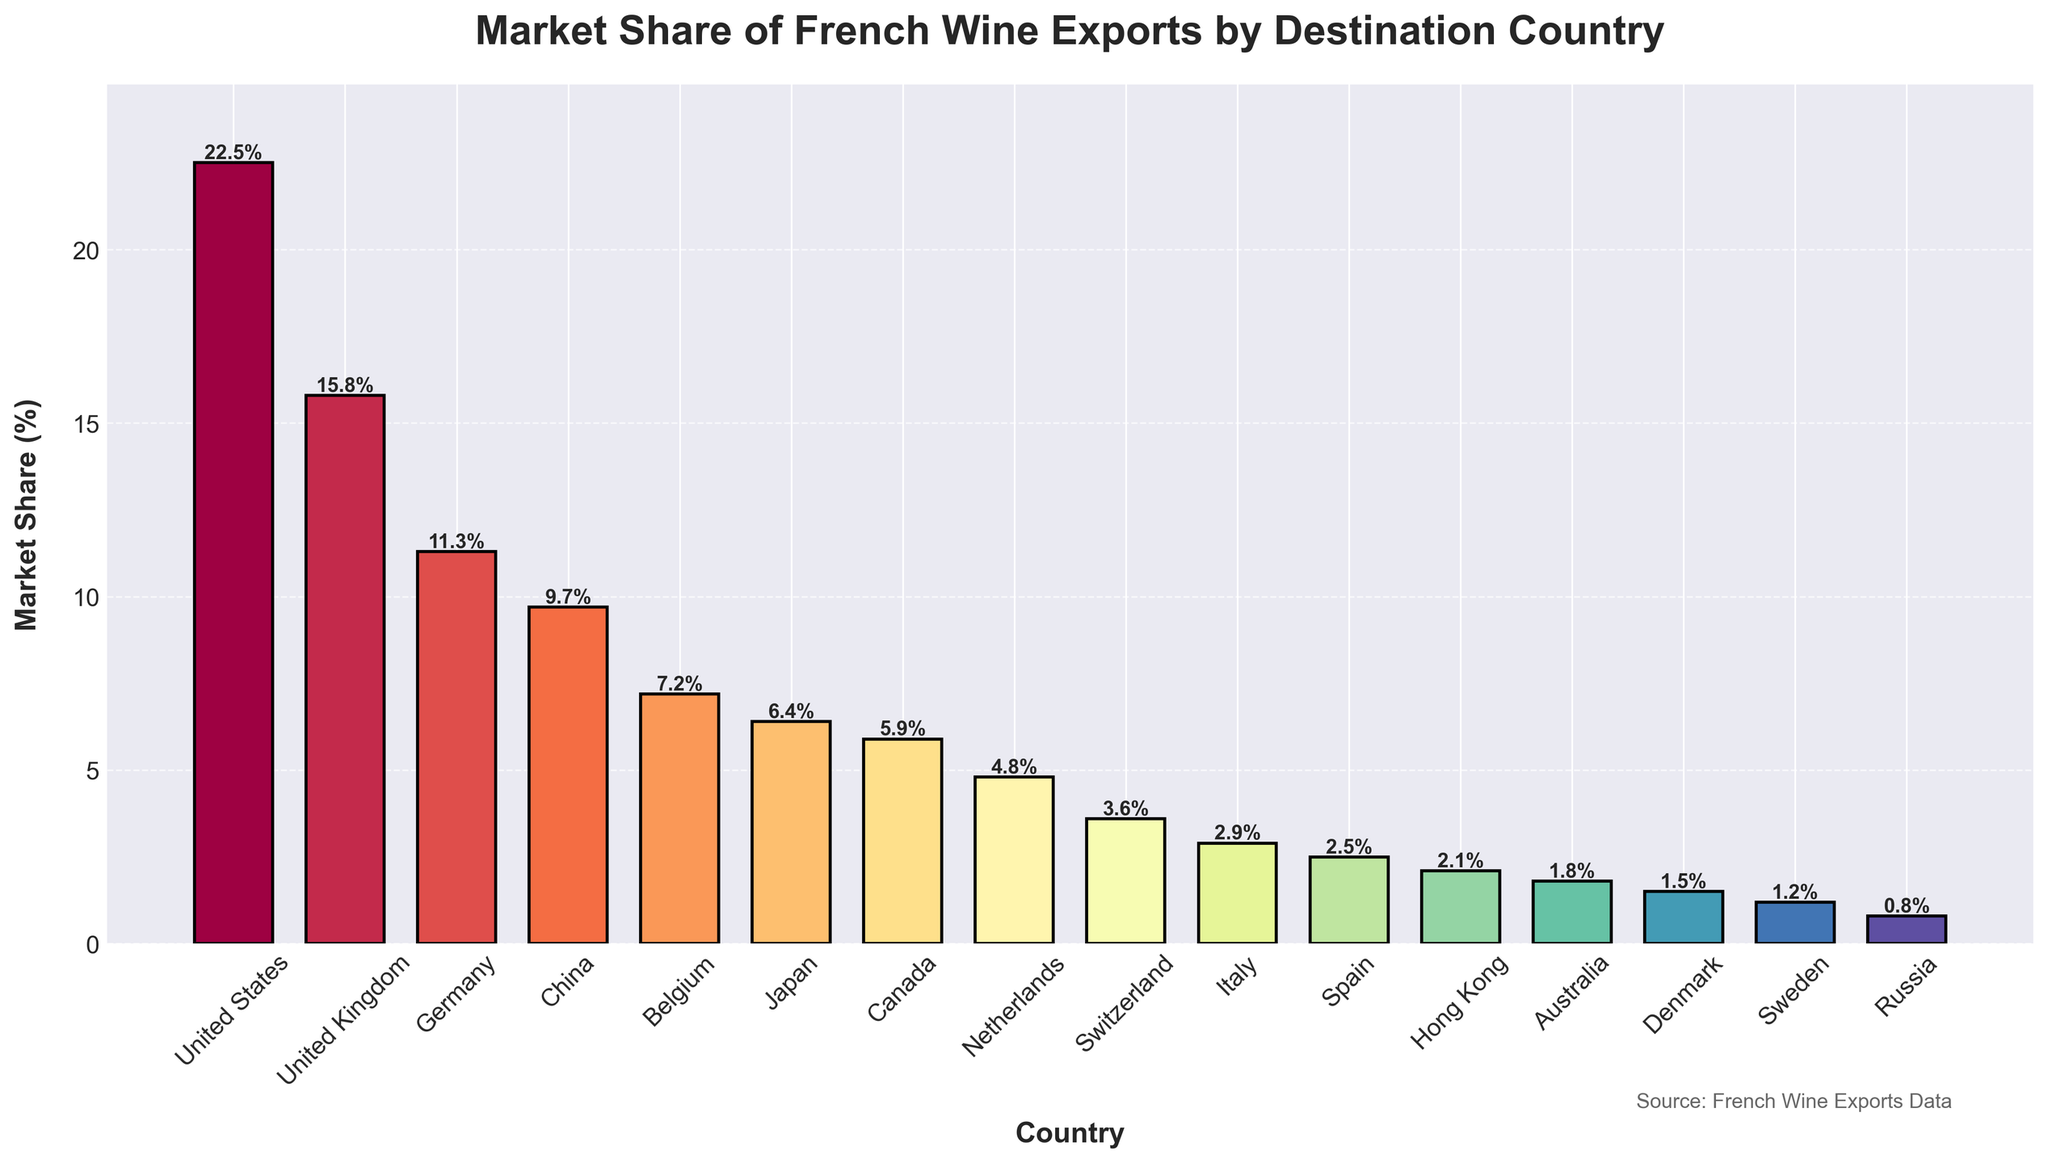What's the market share of the top 5 destination countries combined? To find the combined market share of the top 5 destination countries, sum the individual market shares of the United States (22.5%), United Kingdom (15.8%), Germany (11.3%), China (9.7%), and Belgium (7.2%). The calculation is 22.5% + 15.8% + 11.3% + 9.7% + 7.2% = 66.5%.
Answer: 66.5% Which country has the smallest market share? To determine the country with the smallest market share, look at the bar with the shortest height. The shortest bar corresponds to Russia, with a market share of 0.8%.
Answer: Russia How much higher is the market share of the United States compared to China? Subtract the market share of China (9.7%) from the market share of the United States (22.5%). The calculation is 22.5% - 9.7% = 12.8%.
Answer: 12.8% Which countries have market shares greater than 5% but less than 10%? Identify the bars where the market share percentage is between 5% and 10%. The corresponding countries are China (9.7%), Belgium (7.2%), Japan (6.4%), and Canada (5.9%).
Answer: China, Belgium, Japan, Canada What is the combined market share of all countries with less than 2%? Sum the market shares of Spain (2.5%), Hong Kong (2.1%), Australia (1.8%), Denmark (1.5%), Sweden (1.2%), and Russia (0.8%). The calculation is 2.5% + 2.1% + 1.8% + 1.5% + 1.2% + 0.8% = 9.9%.
Answer: 9.9% What visual attribute helps to distinguish between the countries? Notice that the bars are colored differently using a gradient of colors, which helps to visually distinguish the countries. Additionally, the height of the bars provides information about the market share.
Answer: Color and height of the bars 